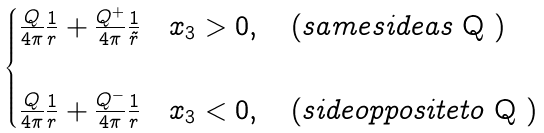<formula> <loc_0><loc_0><loc_500><loc_500>\begin{cases} \frac { Q } { 4 \pi } \frac { 1 } { r } + \frac { Q ^ { + } } { 4 \pi } \frac { 1 } { \tilde { r } } & x _ { 3 } > 0 , \quad ( s a m e s i d e a s $ Q $ ) \\ & \\ \frac { Q } { 4 \pi } \frac { 1 } { r } + \frac { Q ^ { - } } { 4 \pi } \frac { 1 } { r } & x _ { 3 } < 0 , \quad ( s i d e o p p o s i t e t o $ Q $ ) \end{cases}</formula> 